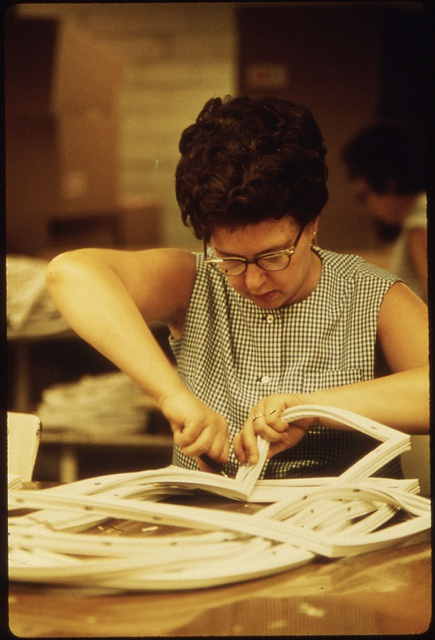Describe the objects in this image and their specific colors. I can see people in black, tan, and brown tones, people in black, maroon, and olive tones, and knife in black, maroon, and olive tones in this image. 